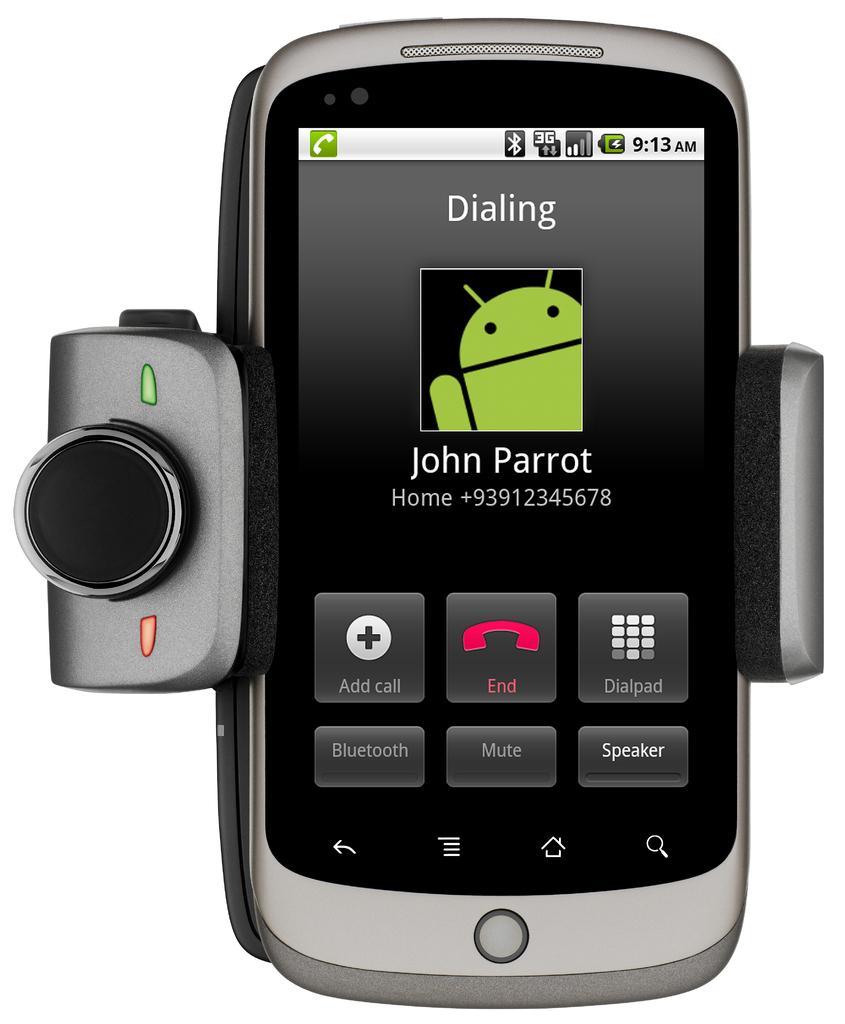Can you describe this image briefly? In this image I can see a mobile, some object and white background. This image looks like an edited photo. 